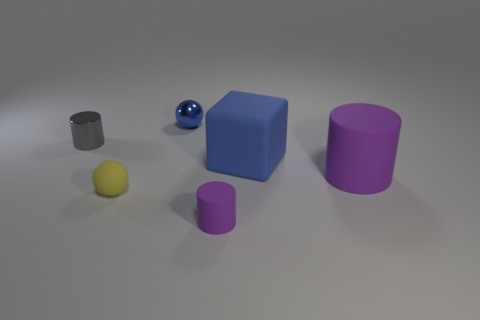What size is the matte cylinder that is behind the small ball in front of the blue metallic thing?
Your answer should be compact. Large. Is the number of big purple cylinders behind the gray metallic object less than the number of cylinders that are to the left of the blue metallic sphere?
Keep it short and to the point. Yes. There is a tiny thing that is in front of the small rubber ball; is its color the same as the big rubber object in front of the big blue matte object?
Offer a very short reply. Yes. There is a thing that is right of the tiny purple cylinder and in front of the large matte block; what material is it made of?
Provide a succinct answer. Rubber. Are there any large cyan rubber cubes?
Your answer should be very brief. No. There is a blue object that is the same material as the small yellow ball; what shape is it?
Provide a succinct answer. Cube. Is the shape of the big blue object the same as the big rubber object that is right of the rubber block?
Your answer should be compact. No. There is a small sphere that is in front of the large thing in front of the large cube; what is its material?
Your answer should be compact. Rubber. How many other objects are there of the same shape as the gray object?
Your response must be concise. 2. There is a purple thing that is to the right of the large blue matte thing; does it have the same shape as the purple thing to the left of the matte cube?
Your response must be concise. Yes. 